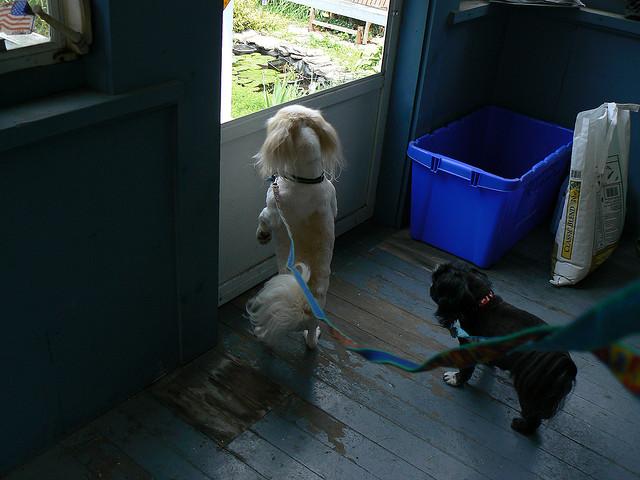Is the black dog standing on all four feet?
Give a very brief answer. Yes. How many dogs are pictured?
Give a very brief answer. 2. What is the beige dog doing?
Be succinct. Standing. 